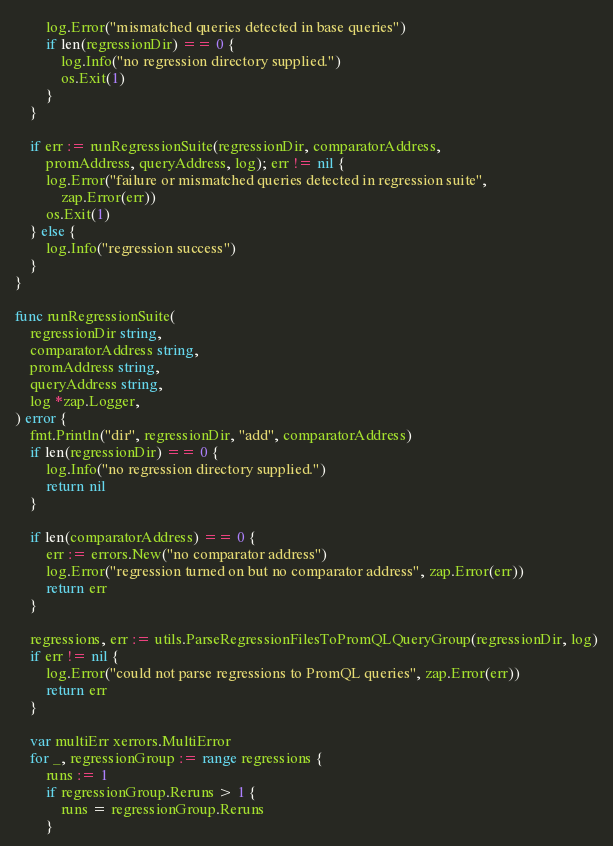Convert code to text. <code><loc_0><loc_0><loc_500><loc_500><_Go_>		log.Error("mismatched queries detected in base queries")
		if len(regressionDir) == 0 {
			log.Info("no regression directory supplied.")
			os.Exit(1)
		}
	}

	if err := runRegressionSuite(regressionDir, comparatorAddress,
		promAddress, queryAddress, log); err != nil {
		log.Error("failure or mismatched queries detected in regression suite",
			zap.Error(err))
		os.Exit(1)
	} else {
		log.Info("regression success")
	}
}

func runRegressionSuite(
	regressionDir string,
	comparatorAddress string,
	promAddress string,
	queryAddress string,
	log *zap.Logger,
) error {
	fmt.Println("dir", regressionDir, "add", comparatorAddress)
	if len(regressionDir) == 0 {
		log.Info("no regression directory supplied.")
		return nil
	}

	if len(comparatorAddress) == 0 {
		err := errors.New("no comparator address")
		log.Error("regression turned on but no comparator address", zap.Error(err))
		return err
	}

	regressions, err := utils.ParseRegressionFilesToPromQLQueryGroup(regressionDir, log)
	if err != nil {
		log.Error("could not parse regressions to PromQL queries", zap.Error(err))
		return err
	}

	var multiErr xerrors.MultiError
	for _, regressionGroup := range regressions {
		runs := 1
		if regressionGroup.Reruns > 1 {
			runs = regressionGroup.Reruns
		}
</code> 